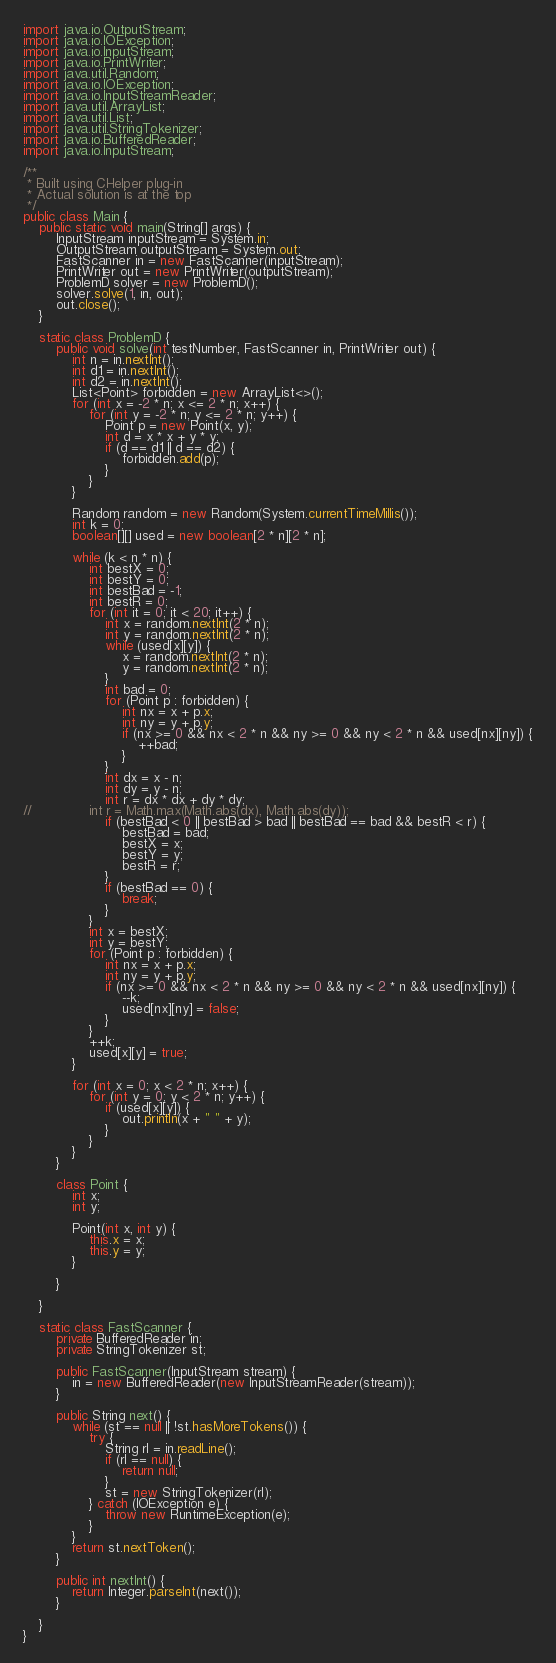<code> <loc_0><loc_0><loc_500><loc_500><_Java_>import java.io.OutputStream;
import java.io.IOException;
import java.io.InputStream;
import java.io.PrintWriter;
import java.util.Random;
import java.io.IOException;
import java.io.InputStreamReader;
import java.util.ArrayList;
import java.util.List;
import java.util.StringTokenizer;
import java.io.BufferedReader;
import java.io.InputStream;

/**
 * Built using CHelper plug-in
 * Actual solution is at the top
 */
public class Main {
	public static void main(String[] args) {
		InputStream inputStream = System.in;
		OutputStream outputStream = System.out;
		FastScanner in = new FastScanner(inputStream);
		PrintWriter out = new PrintWriter(outputStream);
		ProblemD solver = new ProblemD();
		solver.solve(1, in, out);
		out.close();
	}

	static class ProblemD {
		public void solve(int testNumber, FastScanner in, PrintWriter out) {
			int n = in.nextInt();
			int d1 = in.nextInt();
			int d2 = in.nextInt();
			List<Point> forbidden = new ArrayList<>();
			for (int x = -2 * n; x <= 2 * n; x++) {
				for (int y = -2 * n; y <= 2 * n; y++) {
					Point p = new Point(x, y);
					int d = x * x + y * y;
					if (d == d1 || d == d2) {
						forbidden.add(p);
					}
				}
			}

			Random random = new Random(System.currentTimeMillis());
			int k = 0;
			boolean[][] used = new boolean[2 * n][2 * n];

			while (k < n * n) {
				int bestX = 0;
				int bestY = 0;
				int bestBad = -1;
				int bestR = 0;
				for (int it = 0; it < 20; it++) {
					int x = random.nextInt(2 * n);
					int y = random.nextInt(2 * n);
					while (used[x][y]) {
						x = random.nextInt(2 * n);
						y = random.nextInt(2 * n);
					}
					int bad = 0;
					for (Point p : forbidden) {
						int nx = x + p.x;
						int ny = y + p.y;
						if (nx >= 0 && nx < 2 * n && ny >= 0 && ny < 2 * n && used[nx][ny]) {
							++bad;
						}
					}
					int dx = x - n;
					int dy = y - n;
					int r = dx * dx + dy * dy;
//				int r = Math.max(Math.abs(dx), Math.abs(dy));
					if (bestBad < 0 || bestBad > bad || bestBad == bad && bestR < r) {
						bestBad = bad;
						bestX = x;
						bestY = y;
						bestR = r;
					}
					if (bestBad == 0) {
						break;
					}
				}
				int x = bestX;
				int y = bestY;
				for (Point p : forbidden) {
					int nx = x + p.x;
					int ny = y + p.y;
					if (nx >= 0 && nx < 2 * n && ny >= 0 && ny < 2 * n && used[nx][ny]) {
						--k;
						used[nx][ny] = false;
					}
				}
				++k;
				used[x][y] = true;
			}

			for (int x = 0; x < 2 * n; x++) {
				for (int y = 0; y < 2 * n; y++) {
					if (used[x][y]) {
						out.println(x + " " + y);
					}
				}
			}
		}

		class Point {
			int x;
			int y;

			Point(int x, int y) {
				this.x = x;
				this.y = y;
			}

		}

	}

	static class FastScanner {
		private BufferedReader in;
		private StringTokenizer st;

		public FastScanner(InputStream stream) {
			in = new BufferedReader(new InputStreamReader(stream));
		}

		public String next() {
			while (st == null || !st.hasMoreTokens()) {
				try {
					String rl = in.readLine();
					if (rl == null) {
						return null;
					}
					st = new StringTokenizer(rl);
				} catch (IOException e) {
					throw new RuntimeException(e);
				}
			}
			return st.nextToken();
		}

		public int nextInt() {
			return Integer.parseInt(next());
		}

	}
}

</code> 